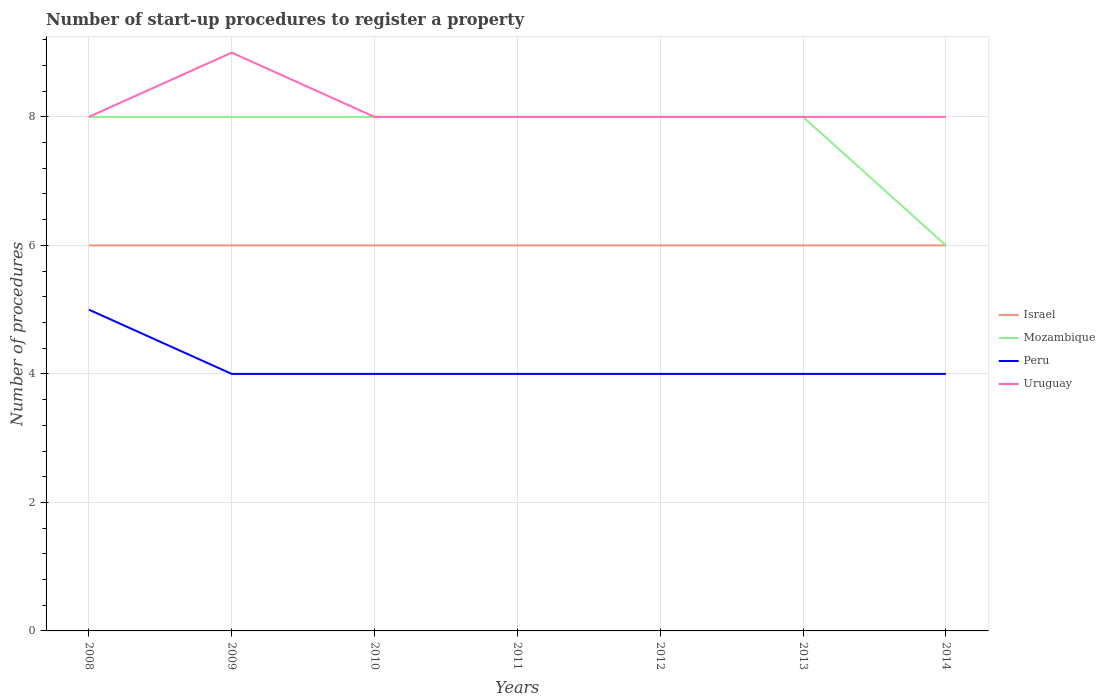Across all years, what is the maximum number of procedures required to register a property in Peru?
Your response must be concise. 4. What is the total number of procedures required to register a property in Peru in the graph?
Provide a succinct answer. 0. What is the difference between the highest and the second highest number of procedures required to register a property in Peru?
Give a very brief answer. 1. What is the difference between the highest and the lowest number of procedures required to register a property in Uruguay?
Your answer should be compact. 1. Is the number of procedures required to register a property in Mozambique strictly greater than the number of procedures required to register a property in Israel over the years?
Make the answer very short. No. How many lines are there?
Your response must be concise. 4. What is the difference between two consecutive major ticks on the Y-axis?
Ensure brevity in your answer.  2. Are the values on the major ticks of Y-axis written in scientific E-notation?
Provide a short and direct response. No. Where does the legend appear in the graph?
Offer a very short reply. Center right. How many legend labels are there?
Provide a succinct answer. 4. How are the legend labels stacked?
Make the answer very short. Vertical. What is the title of the graph?
Your response must be concise. Number of start-up procedures to register a property. Does "Morocco" appear as one of the legend labels in the graph?
Your answer should be compact. No. What is the label or title of the Y-axis?
Make the answer very short. Number of procedures. What is the Number of procedures of Israel in 2008?
Keep it short and to the point. 6. What is the Number of procedures of Peru in 2008?
Ensure brevity in your answer.  5. What is the Number of procedures of Uruguay in 2008?
Make the answer very short. 8. What is the Number of procedures in Israel in 2009?
Keep it short and to the point. 6. What is the Number of procedures of Mozambique in 2009?
Your answer should be very brief. 8. What is the Number of procedures of Peru in 2009?
Offer a terse response. 4. What is the Number of procedures of Uruguay in 2009?
Ensure brevity in your answer.  9. What is the Number of procedures in Israel in 2010?
Offer a very short reply. 6. What is the Number of procedures in Peru in 2010?
Your answer should be compact. 4. What is the Number of procedures in Uruguay in 2010?
Keep it short and to the point. 8. What is the Number of procedures of Israel in 2011?
Provide a short and direct response. 6. What is the Number of procedures of Israel in 2012?
Your response must be concise. 6. What is the Number of procedures of Mozambique in 2012?
Ensure brevity in your answer.  8. What is the Number of procedures in Uruguay in 2012?
Give a very brief answer. 8. What is the Number of procedures of Peru in 2013?
Give a very brief answer. 4. What is the Number of procedures in Uruguay in 2013?
Make the answer very short. 8. What is the Number of procedures in Israel in 2014?
Provide a succinct answer. 6. What is the Number of procedures in Peru in 2014?
Your answer should be very brief. 4. Across all years, what is the maximum Number of procedures of Israel?
Provide a short and direct response. 6. Across all years, what is the maximum Number of procedures in Mozambique?
Your response must be concise. 8. Across all years, what is the minimum Number of procedures in Israel?
Offer a terse response. 6. Across all years, what is the minimum Number of procedures of Mozambique?
Offer a very short reply. 6. What is the total Number of procedures in Mozambique in the graph?
Your answer should be very brief. 54. What is the difference between the Number of procedures of Peru in 2008 and that in 2009?
Make the answer very short. 1. What is the difference between the Number of procedures in Uruguay in 2008 and that in 2009?
Ensure brevity in your answer.  -1. What is the difference between the Number of procedures of Peru in 2008 and that in 2010?
Ensure brevity in your answer.  1. What is the difference between the Number of procedures in Uruguay in 2008 and that in 2010?
Offer a very short reply. 0. What is the difference between the Number of procedures of Israel in 2008 and that in 2011?
Ensure brevity in your answer.  0. What is the difference between the Number of procedures in Mozambique in 2008 and that in 2011?
Give a very brief answer. 0. What is the difference between the Number of procedures in Peru in 2008 and that in 2011?
Your response must be concise. 1. What is the difference between the Number of procedures of Peru in 2008 and that in 2013?
Your answer should be very brief. 1. What is the difference between the Number of procedures of Mozambique in 2008 and that in 2014?
Offer a very short reply. 2. What is the difference between the Number of procedures in Mozambique in 2009 and that in 2010?
Make the answer very short. 0. What is the difference between the Number of procedures in Israel in 2009 and that in 2011?
Give a very brief answer. 0. What is the difference between the Number of procedures in Uruguay in 2009 and that in 2011?
Ensure brevity in your answer.  1. What is the difference between the Number of procedures of Israel in 2009 and that in 2012?
Your answer should be compact. 0. What is the difference between the Number of procedures of Mozambique in 2009 and that in 2012?
Your answer should be very brief. 0. What is the difference between the Number of procedures in Peru in 2009 and that in 2012?
Keep it short and to the point. 0. What is the difference between the Number of procedures in Uruguay in 2009 and that in 2012?
Ensure brevity in your answer.  1. What is the difference between the Number of procedures of Israel in 2009 and that in 2013?
Ensure brevity in your answer.  0. What is the difference between the Number of procedures in Mozambique in 2009 and that in 2013?
Your response must be concise. 0. What is the difference between the Number of procedures in Peru in 2009 and that in 2013?
Ensure brevity in your answer.  0. What is the difference between the Number of procedures in Uruguay in 2009 and that in 2013?
Your response must be concise. 1. What is the difference between the Number of procedures in Israel in 2009 and that in 2014?
Your answer should be very brief. 0. What is the difference between the Number of procedures of Mozambique in 2009 and that in 2014?
Keep it short and to the point. 2. What is the difference between the Number of procedures in Uruguay in 2009 and that in 2014?
Provide a short and direct response. 1. What is the difference between the Number of procedures in Peru in 2010 and that in 2011?
Offer a terse response. 0. What is the difference between the Number of procedures in Peru in 2010 and that in 2012?
Your answer should be very brief. 0. What is the difference between the Number of procedures in Uruguay in 2010 and that in 2013?
Offer a terse response. 0. What is the difference between the Number of procedures of Mozambique in 2010 and that in 2014?
Keep it short and to the point. 2. What is the difference between the Number of procedures in Peru in 2010 and that in 2014?
Provide a short and direct response. 0. What is the difference between the Number of procedures in Mozambique in 2011 and that in 2012?
Your answer should be compact. 0. What is the difference between the Number of procedures in Israel in 2011 and that in 2013?
Keep it short and to the point. 0. What is the difference between the Number of procedures of Mozambique in 2011 and that in 2013?
Give a very brief answer. 0. What is the difference between the Number of procedures of Peru in 2011 and that in 2013?
Give a very brief answer. 0. What is the difference between the Number of procedures of Israel in 2012 and that in 2013?
Offer a terse response. 0. What is the difference between the Number of procedures of Peru in 2012 and that in 2013?
Ensure brevity in your answer.  0. What is the difference between the Number of procedures in Uruguay in 2012 and that in 2013?
Your answer should be compact. 0. What is the difference between the Number of procedures of Peru in 2012 and that in 2014?
Ensure brevity in your answer.  0. What is the difference between the Number of procedures in Israel in 2013 and that in 2014?
Keep it short and to the point. 0. What is the difference between the Number of procedures in Peru in 2013 and that in 2014?
Your response must be concise. 0. What is the difference between the Number of procedures in Uruguay in 2013 and that in 2014?
Make the answer very short. 0. What is the difference between the Number of procedures of Israel in 2008 and the Number of procedures of Mozambique in 2009?
Ensure brevity in your answer.  -2. What is the difference between the Number of procedures in Mozambique in 2008 and the Number of procedures in Uruguay in 2009?
Offer a terse response. -1. What is the difference between the Number of procedures in Israel in 2008 and the Number of procedures in Peru in 2010?
Your answer should be very brief. 2. What is the difference between the Number of procedures in Israel in 2008 and the Number of procedures in Uruguay in 2010?
Your answer should be very brief. -2. What is the difference between the Number of procedures in Mozambique in 2008 and the Number of procedures in Peru in 2010?
Your answer should be compact. 4. What is the difference between the Number of procedures of Peru in 2008 and the Number of procedures of Uruguay in 2010?
Provide a short and direct response. -3. What is the difference between the Number of procedures in Mozambique in 2008 and the Number of procedures in Uruguay in 2011?
Keep it short and to the point. 0. What is the difference between the Number of procedures of Peru in 2008 and the Number of procedures of Uruguay in 2011?
Provide a short and direct response. -3. What is the difference between the Number of procedures of Israel in 2008 and the Number of procedures of Mozambique in 2012?
Give a very brief answer. -2. What is the difference between the Number of procedures of Israel in 2008 and the Number of procedures of Peru in 2012?
Provide a succinct answer. 2. What is the difference between the Number of procedures in Peru in 2008 and the Number of procedures in Uruguay in 2012?
Provide a short and direct response. -3. What is the difference between the Number of procedures in Israel in 2008 and the Number of procedures in Mozambique in 2013?
Provide a short and direct response. -2. What is the difference between the Number of procedures of Mozambique in 2008 and the Number of procedures of Uruguay in 2013?
Offer a terse response. 0. What is the difference between the Number of procedures in Israel in 2008 and the Number of procedures in Mozambique in 2014?
Give a very brief answer. 0. What is the difference between the Number of procedures of Israel in 2008 and the Number of procedures of Peru in 2014?
Ensure brevity in your answer.  2. What is the difference between the Number of procedures of Israel in 2008 and the Number of procedures of Uruguay in 2014?
Offer a very short reply. -2. What is the difference between the Number of procedures in Mozambique in 2008 and the Number of procedures in Peru in 2014?
Your answer should be compact. 4. What is the difference between the Number of procedures in Mozambique in 2008 and the Number of procedures in Uruguay in 2014?
Give a very brief answer. 0. What is the difference between the Number of procedures in Peru in 2008 and the Number of procedures in Uruguay in 2014?
Offer a very short reply. -3. What is the difference between the Number of procedures in Israel in 2009 and the Number of procedures in Mozambique in 2010?
Provide a succinct answer. -2. What is the difference between the Number of procedures in Israel in 2009 and the Number of procedures in Peru in 2010?
Your answer should be very brief. 2. What is the difference between the Number of procedures of Peru in 2009 and the Number of procedures of Uruguay in 2010?
Your answer should be very brief. -4. What is the difference between the Number of procedures in Israel in 2009 and the Number of procedures in Uruguay in 2011?
Ensure brevity in your answer.  -2. What is the difference between the Number of procedures in Israel in 2009 and the Number of procedures in Peru in 2012?
Your response must be concise. 2. What is the difference between the Number of procedures in Israel in 2009 and the Number of procedures in Uruguay in 2012?
Make the answer very short. -2. What is the difference between the Number of procedures in Mozambique in 2009 and the Number of procedures in Uruguay in 2012?
Your answer should be very brief. 0. What is the difference between the Number of procedures of Israel in 2009 and the Number of procedures of Uruguay in 2013?
Make the answer very short. -2. What is the difference between the Number of procedures of Mozambique in 2009 and the Number of procedures of Peru in 2013?
Keep it short and to the point. 4. What is the difference between the Number of procedures in Mozambique in 2009 and the Number of procedures in Peru in 2014?
Keep it short and to the point. 4. What is the difference between the Number of procedures of Mozambique in 2009 and the Number of procedures of Uruguay in 2014?
Your response must be concise. 0. What is the difference between the Number of procedures in Israel in 2010 and the Number of procedures in Uruguay in 2011?
Provide a succinct answer. -2. What is the difference between the Number of procedures of Mozambique in 2010 and the Number of procedures of Peru in 2012?
Give a very brief answer. 4. What is the difference between the Number of procedures of Mozambique in 2010 and the Number of procedures of Uruguay in 2012?
Give a very brief answer. 0. What is the difference between the Number of procedures in Peru in 2010 and the Number of procedures in Uruguay in 2012?
Provide a short and direct response. -4. What is the difference between the Number of procedures in Israel in 2010 and the Number of procedures in Peru in 2013?
Ensure brevity in your answer.  2. What is the difference between the Number of procedures of Israel in 2010 and the Number of procedures of Uruguay in 2013?
Your answer should be compact. -2. What is the difference between the Number of procedures in Mozambique in 2010 and the Number of procedures in Uruguay in 2013?
Your response must be concise. 0. What is the difference between the Number of procedures of Israel in 2010 and the Number of procedures of Mozambique in 2014?
Your answer should be very brief. 0. What is the difference between the Number of procedures of Israel in 2010 and the Number of procedures of Uruguay in 2014?
Offer a terse response. -2. What is the difference between the Number of procedures in Peru in 2010 and the Number of procedures in Uruguay in 2014?
Give a very brief answer. -4. What is the difference between the Number of procedures of Mozambique in 2011 and the Number of procedures of Uruguay in 2012?
Offer a very short reply. 0. What is the difference between the Number of procedures in Peru in 2011 and the Number of procedures in Uruguay in 2012?
Offer a terse response. -4. What is the difference between the Number of procedures in Israel in 2011 and the Number of procedures in Mozambique in 2013?
Your answer should be compact. -2. What is the difference between the Number of procedures of Mozambique in 2011 and the Number of procedures of Uruguay in 2013?
Your response must be concise. 0. What is the difference between the Number of procedures of Israel in 2011 and the Number of procedures of Peru in 2014?
Your answer should be compact. 2. What is the difference between the Number of procedures in Israel in 2011 and the Number of procedures in Uruguay in 2014?
Your answer should be compact. -2. What is the difference between the Number of procedures in Israel in 2012 and the Number of procedures in Peru in 2013?
Give a very brief answer. 2. What is the difference between the Number of procedures of Israel in 2012 and the Number of procedures of Mozambique in 2014?
Your answer should be compact. 0. What is the difference between the Number of procedures in Mozambique in 2012 and the Number of procedures in Peru in 2014?
Your answer should be very brief. 4. What is the difference between the Number of procedures of Israel in 2013 and the Number of procedures of Mozambique in 2014?
Your answer should be very brief. 0. What is the difference between the Number of procedures of Israel in 2013 and the Number of procedures of Peru in 2014?
Make the answer very short. 2. What is the difference between the Number of procedures in Mozambique in 2013 and the Number of procedures in Peru in 2014?
Offer a terse response. 4. What is the average Number of procedures in Mozambique per year?
Give a very brief answer. 7.71. What is the average Number of procedures in Peru per year?
Offer a terse response. 4.14. What is the average Number of procedures of Uruguay per year?
Make the answer very short. 8.14. In the year 2008, what is the difference between the Number of procedures of Israel and Number of procedures of Mozambique?
Offer a terse response. -2. In the year 2009, what is the difference between the Number of procedures in Israel and Number of procedures in Peru?
Your answer should be very brief. 2. In the year 2009, what is the difference between the Number of procedures of Israel and Number of procedures of Uruguay?
Keep it short and to the point. -3. In the year 2009, what is the difference between the Number of procedures of Mozambique and Number of procedures of Uruguay?
Your response must be concise. -1. In the year 2009, what is the difference between the Number of procedures in Peru and Number of procedures in Uruguay?
Offer a terse response. -5. In the year 2011, what is the difference between the Number of procedures of Israel and Number of procedures of Peru?
Keep it short and to the point. 2. In the year 2011, what is the difference between the Number of procedures of Israel and Number of procedures of Uruguay?
Your answer should be compact. -2. In the year 2012, what is the difference between the Number of procedures in Israel and Number of procedures in Mozambique?
Offer a terse response. -2. In the year 2012, what is the difference between the Number of procedures of Israel and Number of procedures of Peru?
Give a very brief answer. 2. In the year 2012, what is the difference between the Number of procedures of Israel and Number of procedures of Uruguay?
Offer a terse response. -2. In the year 2012, what is the difference between the Number of procedures of Mozambique and Number of procedures of Uruguay?
Your response must be concise. 0. In the year 2012, what is the difference between the Number of procedures of Peru and Number of procedures of Uruguay?
Ensure brevity in your answer.  -4. In the year 2013, what is the difference between the Number of procedures of Israel and Number of procedures of Peru?
Ensure brevity in your answer.  2. In the year 2013, what is the difference between the Number of procedures in Israel and Number of procedures in Uruguay?
Keep it short and to the point. -2. In the year 2014, what is the difference between the Number of procedures of Israel and Number of procedures of Peru?
Your answer should be compact. 2. In the year 2014, what is the difference between the Number of procedures in Israel and Number of procedures in Uruguay?
Your answer should be compact. -2. In the year 2014, what is the difference between the Number of procedures of Mozambique and Number of procedures of Peru?
Keep it short and to the point. 2. In the year 2014, what is the difference between the Number of procedures of Mozambique and Number of procedures of Uruguay?
Make the answer very short. -2. What is the ratio of the Number of procedures in Israel in 2008 to that in 2009?
Provide a succinct answer. 1. What is the ratio of the Number of procedures in Mozambique in 2008 to that in 2009?
Your answer should be very brief. 1. What is the ratio of the Number of procedures of Peru in 2008 to that in 2009?
Your response must be concise. 1.25. What is the ratio of the Number of procedures in Israel in 2008 to that in 2010?
Make the answer very short. 1. What is the ratio of the Number of procedures of Peru in 2008 to that in 2010?
Make the answer very short. 1.25. What is the ratio of the Number of procedures in Uruguay in 2008 to that in 2010?
Give a very brief answer. 1. What is the ratio of the Number of procedures in Israel in 2008 to that in 2011?
Your answer should be compact. 1. What is the ratio of the Number of procedures in Mozambique in 2008 to that in 2011?
Your answer should be very brief. 1. What is the ratio of the Number of procedures of Israel in 2008 to that in 2012?
Offer a very short reply. 1. What is the ratio of the Number of procedures in Peru in 2008 to that in 2012?
Provide a succinct answer. 1.25. What is the ratio of the Number of procedures in Uruguay in 2008 to that in 2012?
Your answer should be very brief. 1. What is the ratio of the Number of procedures in Israel in 2008 to that in 2013?
Your answer should be very brief. 1. What is the ratio of the Number of procedures of Mozambique in 2008 to that in 2013?
Give a very brief answer. 1. What is the ratio of the Number of procedures of Peru in 2008 to that in 2014?
Offer a very short reply. 1.25. What is the ratio of the Number of procedures in Peru in 2009 to that in 2010?
Your response must be concise. 1. What is the ratio of the Number of procedures of Uruguay in 2009 to that in 2010?
Your answer should be compact. 1.12. What is the ratio of the Number of procedures in Israel in 2009 to that in 2011?
Your response must be concise. 1. What is the ratio of the Number of procedures in Mozambique in 2009 to that in 2011?
Your answer should be very brief. 1. What is the ratio of the Number of procedures of Peru in 2009 to that in 2011?
Your answer should be compact. 1. What is the ratio of the Number of procedures of Uruguay in 2009 to that in 2011?
Make the answer very short. 1.12. What is the ratio of the Number of procedures in Israel in 2009 to that in 2012?
Make the answer very short. 1. What is the ratio of the Number of procedures of Mozambique in 2009 to that in 2012?
Your answer should be very brief. 1. What is the ratio of the Number of procedures of Peru in 2009 to that in 2012?
Your response must be concise. 1. What is the ratio of the Number of procedures in Mozambique in 2009 to that in 2013?
Offer a very short reply. 1. What is the ratio of the Number of procedures of Peru in 2009 to that in 2013?
Ensure brevity in your answer.  1. What is the ratio of the Number of procedures in Uruguay in 2009 to that in 2013?
Keep it short and to the point. 1.12. What is the ratio of the Number of procedures of Mozambique in 2009 to that in 2014?
Offer a terse response. 1.33. What is the ratio of the Number of procedures of Peru in 2009 to that in 2014?
Make the answer very short. 1. What is the ratio of the Number of procedures in Israel in 2010 to that in 2011?
Keep it short and to the point. 1. What is the ratio of the Number of procedures in Mozambique in 2010 to that in 2011?
Keep it short and to the point. 1. What is the ratio of the Number of procedures in Uruguay in 2010 to that in 2011?
Provide a succinct answer. 1. What is the ratio of the Number of procedures of Peru in 2010 to that in 2012?
Your answer should be very brief. 1. What is the ratio of the Number of procedures of Israel in 2010 to that in 2013?
Offer a very short reply. 1. What is the ratio of the Number of procedures of Mozambique in 2010 to that in 2013?
Your response must be concise. 1. What is the ratio of the Number of procedures of Mozambique in 2010 to that in 2014?
Give a very brief answer. 1.33. What is the ratio of the Number of procedures in Israel in 2011 to that in 2012?
Your answer should be compact. 1. What is the ratio of the Number of procedures of Peru in 2011 to that in 2012?
Provide a short and direct response. 1. What is the ratio of the Number of procedures in Uruguay in 2011 to that in 2013?
Your response must be concise. 1. What is the ratio of the Number of procedures in Mozambique in 2011 to that in 2014?
Ensure brevity in your answer.  1.33. What is the ratio of the Number of procedures in Israel in 2012 to that in 2013?
Keep it short and to the point. 1. What is the ratio of the Number of procedures of Peru in 2012 to that in 2013?
Ensure brevity in your answer.  1. What is the ratio of the Number of procedures in Uruguay in 2012 to that in 2013?
Provide a succinct answer. 1. What is the ratio of the Number of procedures in Israel in 2012 to that in 2014?
Ensure brevity in your answer.  1. What is the ratio of the Number of procedures in Mozambique in 2012 to that in 2014?
Keep it short and to the point. 1.33. What is the ratio of the Number of procedures in Mozambique in 2013 to that in 2014?
Your response must be concise. 1.33. What is the ratio of the Number of procedures in Peru in 2013 to that in 2014?
Provide a short and direct response. 1. What is the difference between the highest and the second highest Number of procedures in Mozambique?
Keep it short and to the point. 0. What is the difference between the highest and the lowest Number of procedures in Israel?
Offer a very short reply. 0. What is the difference between the highest and the lowest Number of procedures of Uruguay?
Make the answer very short. 1. 